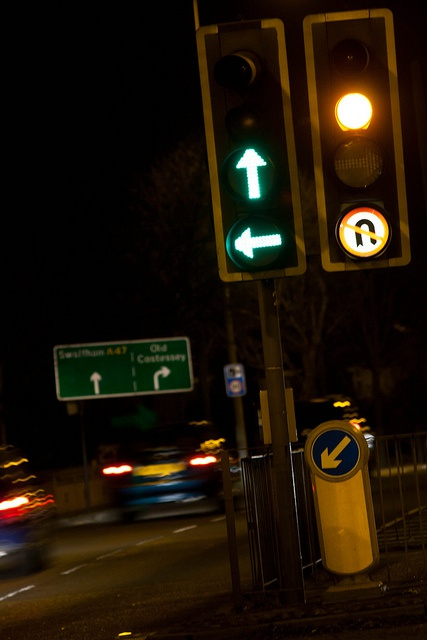Describe the objects in this image and their specific colors. I can see traffic light in black, maroon, olive, and white tones, traffic light in black, maroon, white, and brown tones, car in black, maroon, orange, and ivory tones, and car in black, maroon, brown, and red tones in this image. 